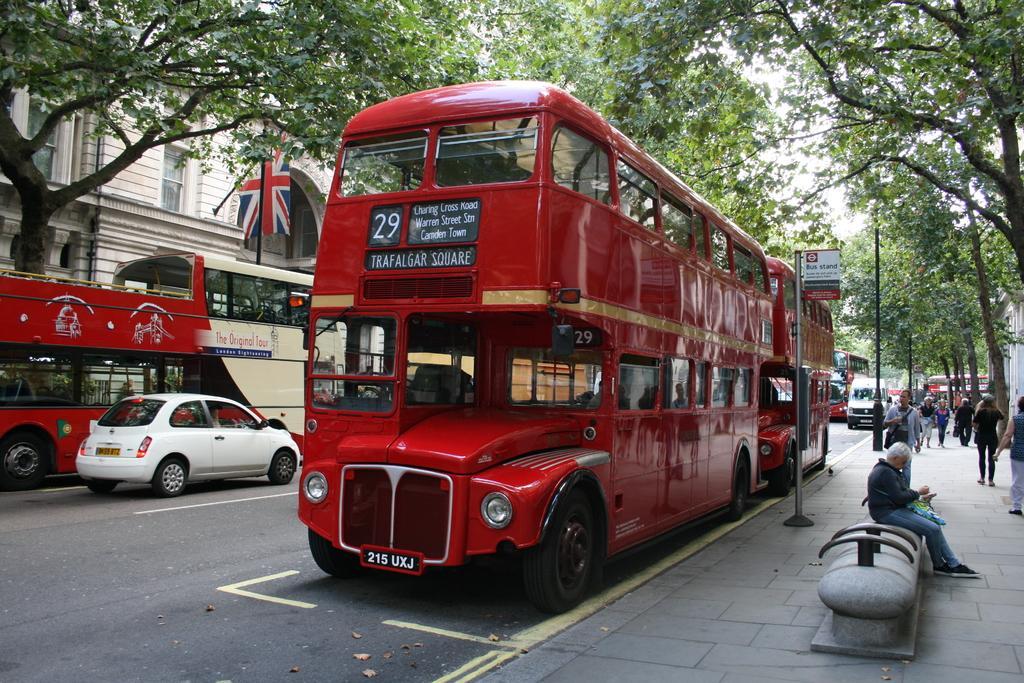Could you give a brief overview of what you see in this image? In this picture I can observe buses and cars on the road. On the right side there is a footpath on which some people are walking. I can observe some trees on either sides of the road. On the left side I can observe a building. In the background there is sky. 